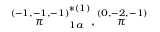<formula> <loc_0><loc_0><loc_500><loc_500>\stackrel { ( - 1 , - 1 , - 1 ) } { \pi } _ { 1 a } ^ { * ( 1 ) } , \stackrel { ( 0 , - 2 , - 1 ) } { \pi }</formula> 